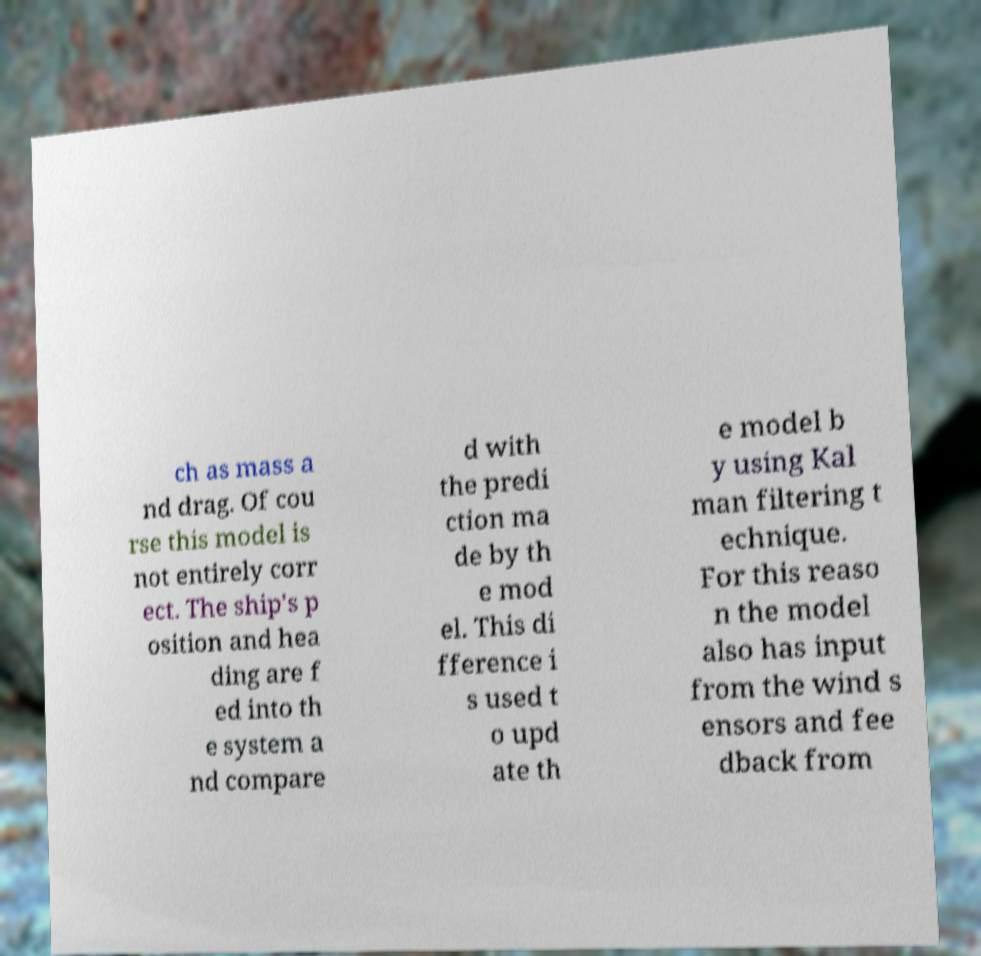Please identify and transcribe the text found in this image. ch as mass a nd drag. Of cou rse this model is not entirely corr ect. The ship's p osition and hea ding are f ed into th e system a nd compare d with the predi ction ma de by th e mod el. This di fference i s used t o upd ate th e model b y using Kal man filtering t echnique. For this reaso n the model also has input from the wind s ensors and fee dback from 